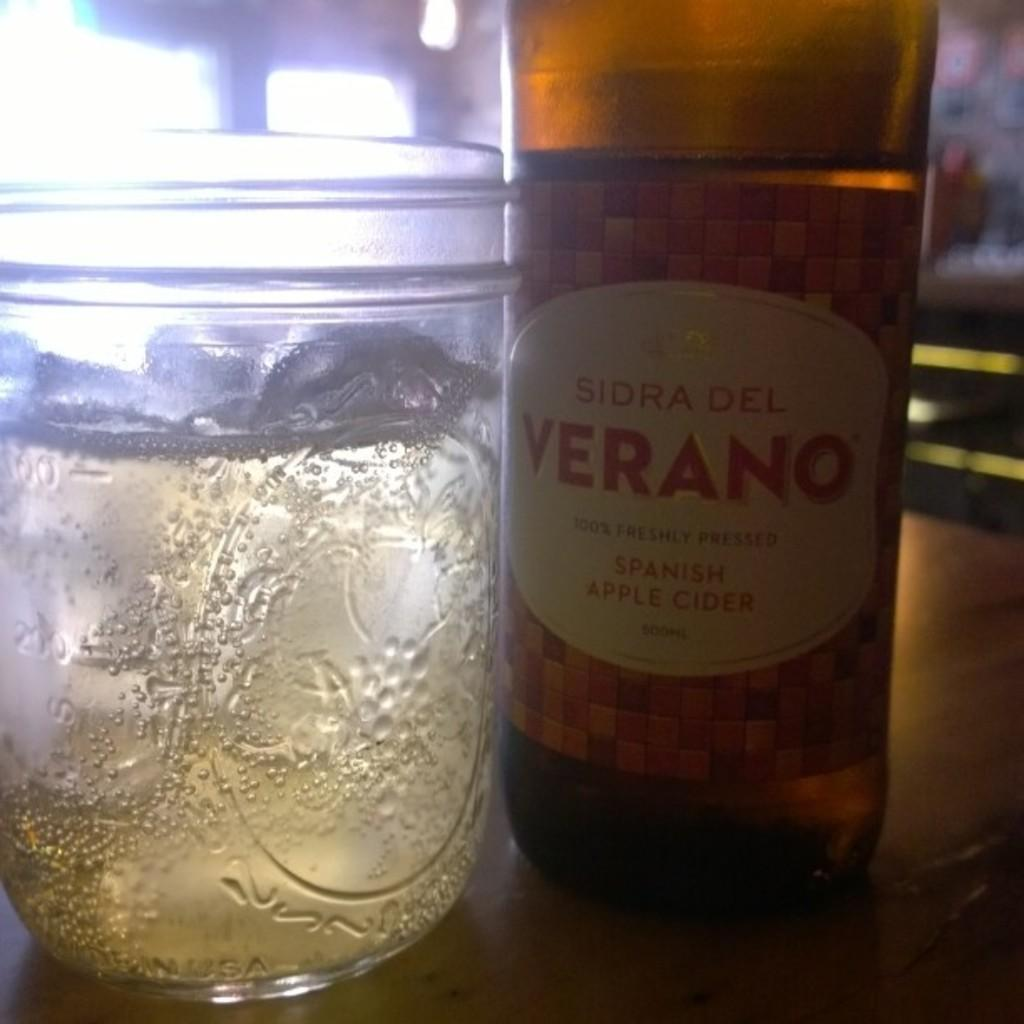Provide a one-sentence caption for the provided image. spanish apple cider bpttle and glass cup on the table. 